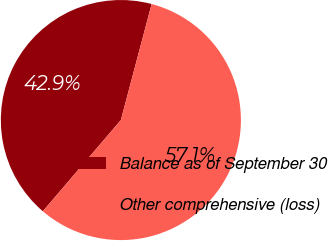Convert chart to OTSL. <chart><loc_0><loc_0><loc_500><loc_500><pie_chart><fcel>Balance as of September 30<fcel>Other comprehensive (loss)<nl><fcel>42.86%<fcel>57.14%<nl></chart> 